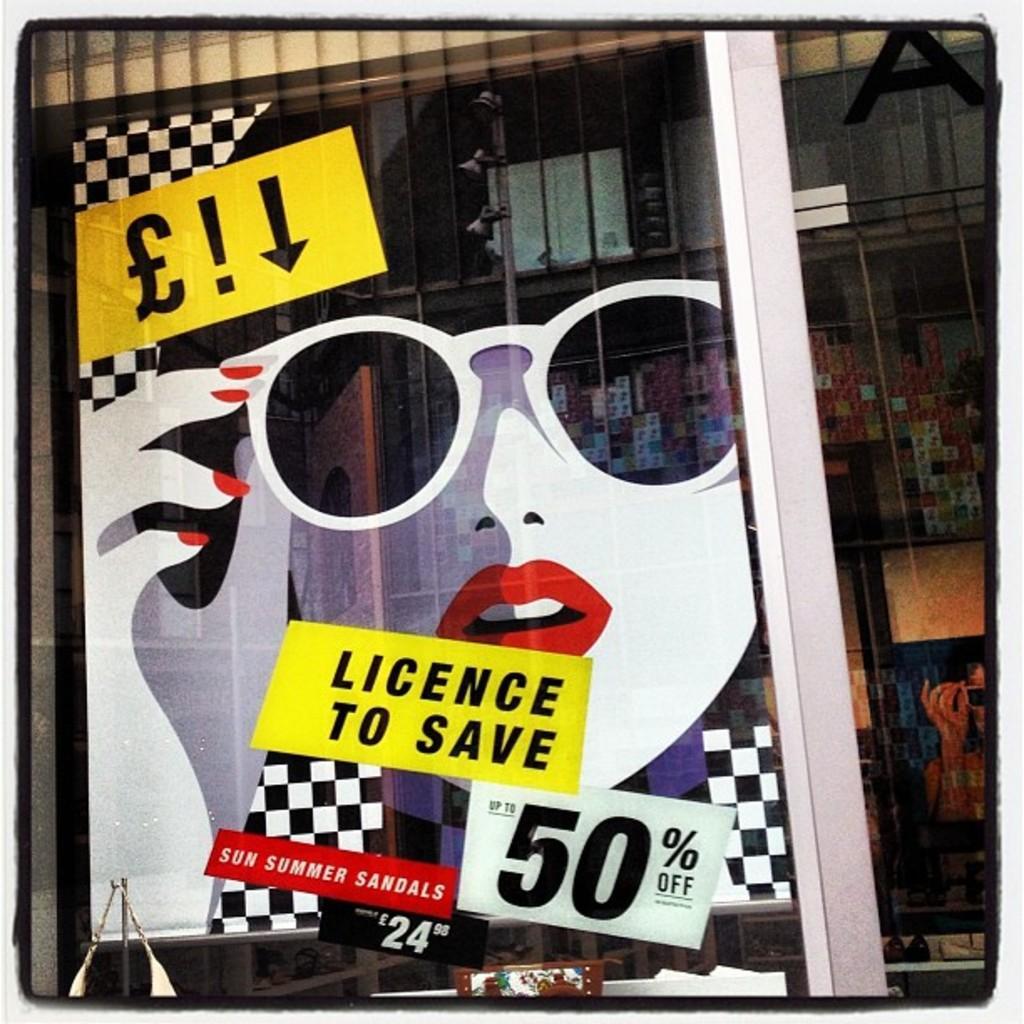Could you give a brief overview of what you see in this image? In this image we can see stickers and posters on the glass door. Through the glass we can see objects. 